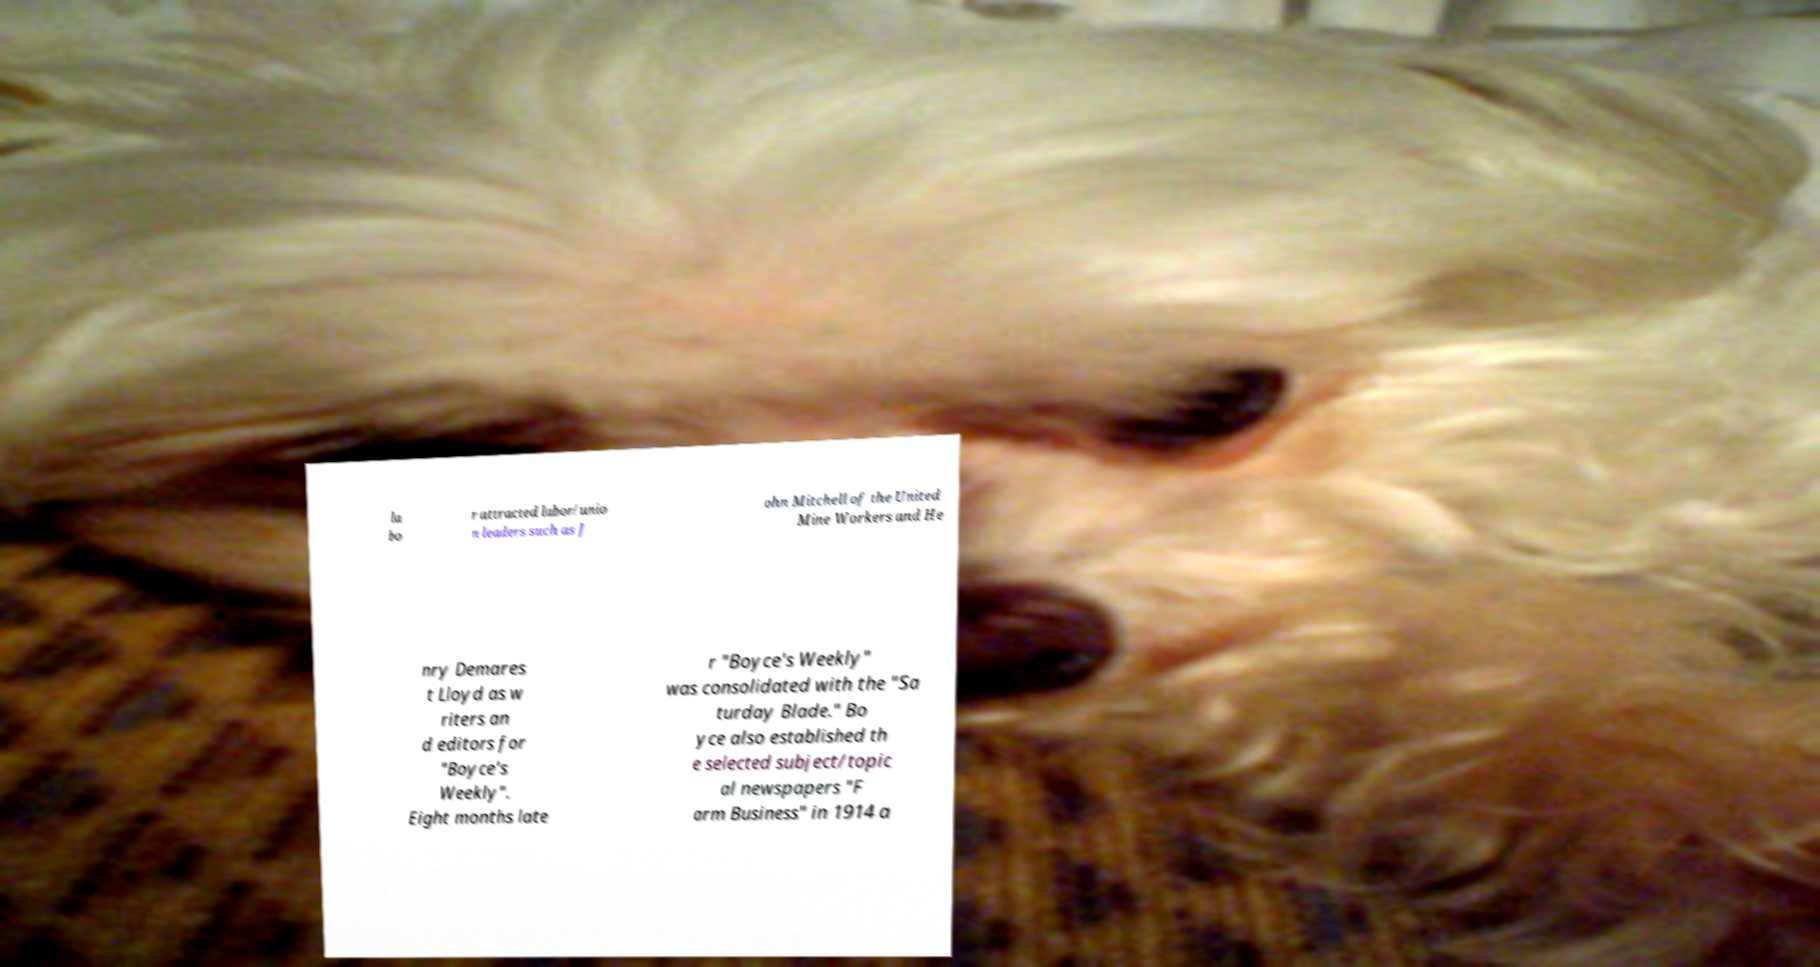Can you accurately transcribe the text from the provided image for me? la bo r attracted labor/unio n leaders such as J ohn Mitchell of the United Mine Workers and He nry Demares t Lloyd as w riters an d editors for "Boyce's Weekly". Eight months late r "Boyce's Weekly" was consolidated with the "Sa turday Blade." Bo yce also established th e selected subject/topic al newspapers "F arm Business" in 1914 a 